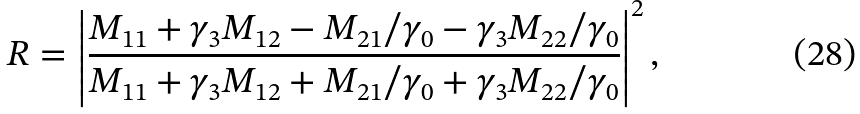Convert formula to latex. <formula><loc_0><loc_0><loc_500><loc_500>R = \left | \frac { M _ { 1 1 } + \gamma _ { 3 } M _ { 1 2 } - M _ { 2 1 } / \gamma _ { 0 } - \gamma _ { 3 } M _ { 2 2 } / \gamma _ { 0 } } { M _ { 1 1 } + \gamma _ { 3 } M _ { 1 2 } + M _ { 2 1 } / \gamma _ { 0 } + \gamma _ { 3 } M _ { 2 2 } / \gamma _ { 0 } } \right | ^ { 2 } ,</formula> 